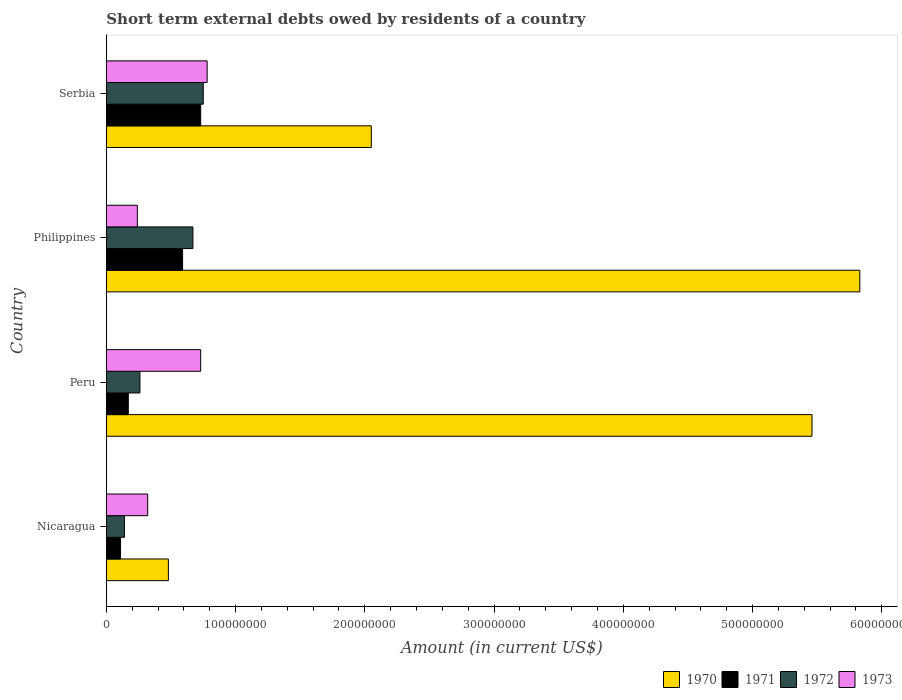How many groups of bars are there?
Ensure brevity in your answer.  4. How many bars are there on the 3rd tick from the top?
Provide a short and direct response. 4. How many bars are there on the 4th tick from the bottom?
Your response must be concise. 4. What is the label of the 4th group of bars from the top?
Make the answer very short. Nicaragua. What is the amount of short-term external debts owed by residents in 1972 in Peru?
Make the answer very short. 2.60e+07. Across all countries, what is the maximum amount of short-term external debts owed by residents in 1970?
Make the answer very short. 5.83e+08. Across all countries, what is the minimum amount of short-term external debts owed by residents in 1971?
Offer a very short reply. 1.10e+07. In which country was the amount of short-term external debts owed by residents in 1973 maximum?
Offer a very short reply. Serbia. In which country was the amount of short-term external debts owed by residents in 1971 minimum?
Offer a very short reply. Nicaragua. What is the total amount of short-term external debts owed by residents in 1970 in the graph?
Keep it short and to the point. 1.38e+09. What is the difference between the amount of short-term external debts owed by residents in 1970 in Nicaragua and that in Serbia?
Your answer should be compact. -1.57e+08. What is the average amount of short-term external debts owed by residents in 1970 per country?
Provide a succinct answer. 3.46e+08. What is the difference between the amount of short-term external debts owed by residents in 1971 and amount of short-term external debts owed by residents in 1973 in Serbia?
Provide a short and direct response. -5.00e+06. In how many countries, is the amount of short-term external debts owed by residents in 1972 greater than 400000000 US$?
Your answer should be compact. 0. What is the ratio of the amount of short-term external debts owed by residents in 1972 in Nicaragua to that in Serbia?
Your answer should be compact. 0.19. Is the amount of short-term external debts owed by residents in 1971 in Philippines less than that in Serbia?
Ensure brevity in your answer.  Yes. Is the difference between the amount of short-term external debts owed by residents in 1971 in Nicaragua and Peru greater than the difference between the amount of short-term external debts owed by residents in 1973 in Nicaragua and Peru?
Keep it short and to the point. Yes. What is the difference between the highest and the second highest amount of short-term external debts owed by residents in 1971?
Provide a short and direct response. 1.40e+07. What is the difference between the highest and the lowest amount of short-term external debts owed by residents in 1970?
Make the answer very short. 5.35e+08. What does the 3rd bar from the top in Peru represents?
Ensure brevity in your answer.  1971. How many bars are there?
Offer a terse response. 16. Are all the bars in the graph horizontal?
Offer a very short reply. Yes. What is the difference between two consecutive major ticks on the X-axis?
Provide a succinct answer. 1.00e+08. Are the values on the major ticks of X-axis written in scientific E-notation?
Offer a terse response. No. Where does the legend appear in the graph?
Offer a terse response. Bottom right. How many legend labels are there?
Give a very brief answer. 4. How are the legend labels stacked?
Provide a short and direct response. Horizontal. What is the title of the graph?
Offer a very short reply. Short term external debts owed by residents of a country. Does "1963" appear as one of the legend labels in the graph?
Offer a very short reply. No. What is the label or title of the X-axis?
Your response must be concise. Amount (in current US$). What is the label or title of the Y-axis?
Provide a short and direct response. Country. What is the Amount (in current US$) of 1970 in Nicaragua?
Your response must be concise. 4.80e+07. What is the Amount (in current US$) in 1971 in Nicaragua?
Ensure brevity in your answer.  1.10e+07. What is the Amount (in current US$) in 1972 in Nicaragua?
Offer a very short reply. 1.40e+07. What is the Amount (in current US$) of 1973 in Nicaragua?
Keep it short and to the point. 3.20e+07. What is the Amount (in current US$) in 1970 in Peru?
Offer a very short reply. 5.46e+08. What is the Amount (in current US$) of 1971 in Peru?
Provide a succinct answer. 1.70e+07. What is the Amount (in current US$) in 1972 in Peru?
Keep it short and to the point. 2.60e+07. What is the Amount (in current US$) in 1973 in Peru?
Ensure brevity in your answer.  7.30e+07. What is the Amount (in current US$) in 1970 in Philippines?
Provide a short and direct response. 5.83e+08. What is the Amount (in current US$) in 1971 in Philippines?
Make the answer very short. 5.90e+07. What is the Amount (in current US$) of 1972 in Philippines?
Offer a very short reply. 6.70e+07. What is the Amount (in current US$) of 1973 in Philippines?
Ensure brevity in your answer.  2.40e+07. What is the Amount (in current US$) of 1970 in Serbia?
Your answer should be compact. 2.05e+08. What is the Amount (in current US$) in 1971 in Serbia?
Keep it short and to the point. 7.30e+07. What is the Amount (in current US$) in 1972 in Serbia?
Ensure brevity in your answer.  7.50e+07. What is the Amount (in current US$) in 1973 in Serbia?
Your answer should be compact. 7.80e+07. Across all countries, what is the maximum Amount (in current US$) of 1970?
Offer a terse response. 5.83e+08. Across all countries, what is the maximum Amount (in current US$) of 1971?
Give a very brief answer. 7.30e+07. Across all countries, what is the maximum Amount (in current US$) in 1972?
Your answer should be very brief. 7.50e+07. Across all countries, what is the maximum Amount (in current US$) in 1973?
Offer a terse response. 7.80e+07. Across all countries, what is the minimum Amount (in current US$) of 1970?
Offer a terse response. 4.80e+07. Across all countries, what is the minimum Amount (in current US$) in 1971?
Provide a succinct answer. 1.10e+07. Across all countries, what is the minimum Amount (in current US$) in 1972?
Make the answer very short. 1.40e+07. Across all countries, what is the minimum Amount (in current US$) of 1973?
Your answer should be very brief. 2.40e+07. What is the total Amount (in current US$) of 1970 in the graph?
Offer a terse response. 1.38e+09. What is the total Amount (in current US$) of 1971 in the graph?
Your answer should be very brief. 1.60e+08. What is the total Amount (in current US$) of 1972 in the graph?
Provide a succinct answer. 1.82e+08. What is the total Amount (in current US$) of 1973 in the graph?
Provide a short and direct response. 2.07e+08. What is the difference between the Amount (in current US$) in 1970 in Nicaragua and that in Peru?
Your response must be concise. -4.98e+08. What is the difference between the Amount (in current US$) in 1971 in Nicaragua and that in Peru?
Your answer should be very brief. -6.00e+06. What is the difference between the Amount (in current US$) in 1972 in Nicaragua and that in Peru?
Keep it short and to the point. -1.20e+07. What is the difference between the Amount (in current US$) in 1973 in Nicaragua and that in Peru?
Provide a short and direct response. -4.10e+07. What is the difference between the Amount (in current US$) in 1970 in Nicaragua and that in Philippines?
Offer a very short reply. -5.35e+08. What is the difference between the Amount (in current US$) in 1971 in Nicaragua and that in Philippines?
Offer a very short reply. -4.80e+07. What is the difference between the Amount (in current US$) in 1972 in Nicaragua and that in Philippines?
Give a very brief answer. -5.30e+07. What is the difference between the Amount (in current US$) in 1973 in Nicaragua and that in Philippines?
Give a very brief answer. 8.00e+06. What is the difference between the Amount (in current US$) of 1970 in Nicaragua and that in Serbia?
Offer a very short reply. -1.57e+08. What is the difference between the Amount (in current US$) in 1971 in Nicaragua and that in Serbia?
Your response must be concise. -6.20e+07. What is the difference between the Amount (in current US$) of 1972 in Nicaragua and that in Serbia?
Your answer should be very brief. -6.10e+07. What is the difference between the Amount (in current US$) of 1973 in Nicaragua and that in Serbia?
Keep it short and to the point. -4.60e+07. What is the difference between the Amount (in current US$) of 1970 in Peru and that in Philippines?
Make the answer very short. -3.70e+07. What is the difference between the Amount (in current US$) of 1971 in Peru and that in Philippines?
Give a very brief answer. -4.20e+07. What is the difference between the Amount (in current US$) in 1972 in Peru and that in Philippines?
Make the answer very short. -4.10e+07. What is the difference between the Amount (in current US$) of 1973 in Peru and that in Philippines?
Offer a very short reply. 4.90e+07. What is the difference between the Amount (in current US$) of 1970 in Peru and that in Serbia?
Ensure brevity in your answer.  3.41e+08. What is the difference between the Amount (in current US$) in 1971 in Peru and that in Serbia?
Provide a succinct answer. -5.60e+07. What is the difference between the Amount (in current US$) in 1972 in Peru and that in Serbia?
Provide a short and direct response. -4.90e+07. What is the difference between the Amount (in current US$) in 1973 in Peru and that in Serbia?
Ensure brevity in your answer.  -5.00e+06. What is the difference between the Amount (in current US$) of 1970 in Philippines and that in Serbia?
Your answer should be compact. 3.78e+08. What is the difference between the Amount (in current US$) of 1971 in Philippines and that in Serbia?
Provide a short and direct response. -1.40e+07. What is the difference between the Amount (in current US$) in 1972 in Philippines and that in Serbia?
Offer a terse response. -8.00e+06. What is the difference between the Amount (in current US$) in 1973 in Philippines and that in Serbia?
Your answer should be compact. -5.40e+07. What is the difference between the Amount (in current US$) of 1970 in Nicaragua and the Amount (in current US$) of 1971 in Peru?
Give a very brief answer. 3.10e+07. What is the difference between the Amount (in current US$) of 1970 in Nicaragua and the Amount (in current US$) of 1972 in Peru?
Your response must be concise. 2.20e+07. What is the difference between the Amount (in current US$) in 1970 in Nicaragua and the Amount (in current US$) in 1973 in Peru?
Your response must be concise. -2.50e+07. What is the difference between the Amount (in current US$) in 1971 in Nicaragua and the Amount (in current US$) in 1972 in Peru?
Give a very brief answer. -1.50e+07. What is the difference between the Amount (in current US$) in 1971 in Nicaragua and the Amount (in current US$) in 1973 in Peru?
Offer a very short reply. -6.20e+07. What is the difference between the Amount (in current US$) in 1972 in Nicaragua and the Amount (in current US$) in 1973 in Peru?
Make the answer very short. -5.90e+07. What is the difference between the Amount (in current US$) in 1970 in Nicaragua and the Amount (in current US$) in 1971 in Philippines?
Ensure brevity in your answer.  -1.10e+07. What is the difference between the Amount (in current US$) in 1970 in Nicaragua and the Amount (in current US$) in 1972 in Philippines?
Make the answer very short. -1.90e+07. What is the difference between the Amount (in current US$) in 1970 in Nicaragua and the Amount (in current US$) in 1973 in Philippines?
Your answer should be compact. 2.40e+07. What is the difference between the Amount (in current US$) of 1971 in Nicaragua and the Amount (in current US$) of 1972 in Philippines?
Your response must be concise. -5.60e+07. What is the difference between the Amount (in current US$) in 1971 in Nicaragua and the Amount (in current US$) in 1973 in Philippines?
Offer a terse response. -1.30e+07. What is the difference between the Amount (in current US$) in 1972 in Nicaragua and the Amount (in current US$) in 1973 in Philippines?
Ensure brevity in your answer.  -1.00e+07. What is the difference between the Amount (in current US$) of 1970 in Nicaragua and the Amount (in current US$) of 1971 in Serbia?
Make the answer very short. -2.50e+07. What is the difference between the Amount (in current US$) of 1970 in Nicaragua and the Amount (in current US$) of 1972 in Serbia?
Offer a very short reply. -2.70e+07. What is the difference between the Amount (in current US$) in 1970 in Nicaragua and the Amount (in current US$) in 1973 in Serbia?
Offer a terse response. -3.00e+07. What is the difference between the Amount (in current US$) of 1971 in Nicaragua and the Amount (in current US$) of 1972 in Serbia?
Give a very brief answer. -6.40e+07. What is the difference between the Amount (in current US$) of 1971 in Nicaragua and the Amount (in current US$) of 1973 in Serbia?
Ensure brevity in your answer.  -6.70e+07. What is the difference between the Amount (in current US$) of 1972 in Nicaragua and the Amount (in current US$) of 1973 in Serbia?
Your answer should be compact. -6.40e+07. What is the difference between the Amount (in current US$) in 1970 in Peru and the Amount (in current US$) in 1971 in Philippines?
Your response must be concise. 4.87e+08. What is the difference between the Amount (in current US$) in 1970 in Peru and the Amount (in current US$) in 1972 in Philippines?
Make the answer very short. 4.79e+08. What is the difference between the Amount (in current US$) of 1970 in Peru and the Amount (in current US$) of 1973 in Philippines?
Your answer should be very brief. 5.22e+08. What is the difference between the Amount (in current US$) in 1971 in Peru and the Amount (in current US$) in 1972 in Philippines?
Your response must be concise. -5.00e+07. What is the difference between the Amount (in current US$) of 1971 in Peru and the Amount (in current US$) of 1973 in Philippines?
Offer a terse response. -7.00e+06. What is the difference between the Amount (in current US$) in 1972 in Peru and the Amount (in current US$) in 1973 in Philippines?
Your answer should be compact. 2.00e+06. What is the difference between the Amount (in current US$) in 1970 in Peru and the Amount (in current US$) in 1971 in Serbia?
Provide a short and direct response. 4.73e+08. What is the difference between the Amount (in current US$) in 1970 in Peru and the Amount (in current US$) in 1972 in Serbia?
Keep it short and to the point. 4.71e+08. What is the difference between the Amount (in current US$) of 1970 in Peru and the Amount (in current US$) of 1973 in Serbia?
Offer a terse response. 4.68e+08. What is the difference between the Amount (in current US$) of 1971 in Peru and the Amount (in current US$) of 1972 in Serbia?
Offer a terse response. -5.80e+07. What is the difference between the Amount (in current US$) of 1971 in Peru and the Amount (in current US$) of 1973 in Serbia?
Make the answer very short. -6.10e+07. What is the difference between the Amount (in current US$) in 1972 in Peru and the Amount (in current US$) in 1973 in Serbia?
Offer a terse response. -5.20e+07. What is the difference between the Amount (in current US$) of 1970 in Philippines and the Amount (in current US$) of 1971 in Serbia?
Provide a succinct answer. 5.10e+08. What is the difference between the Amount (in current US$) of 1970 in Philippines and the Amount (in current US$) of 1972 in Serbia?
Provide a short and direct response. 5.08e+08. What is the difference between the Amount (in current US$) in 1970 in Philippines and the Amount (in current US$) in 1973 in Serbia?
Your answer should be compact. 5.05e+08. What is the difference between the Amount (in current US$) in 1971 in Philippines and the Amount (in current US$) in 1972 in Serbia?
Make the answer very short. -1.60e+07. What is the difference between the Amount (in current US$) of 1971 in Philippines and the Amount (in current US$) of 1973 in Serbia?
Your answer should be very brief. -1.90e+07. What is the difference between the Amount (in current US$) in 1972 in Philippines and the Amount (in current US$) in 1973 in Serbia?
Keep it short and to the point. -1.10e+07. What is the average Amount (in current US$) in 1970 per country?
Offer a very short reply. 3.46e+08. What is the average Amount (in current US$) in 1971 per country?
Offer a very short reply. 4.00e+07. What is the average Amount (in current US$) of 1972 per country?
Keep it short and to the point. 4.55e+07. What is the average Amount (in current US$) in 1973 per country?
Offer a very short reply. 5.18e+07. What is the difference between the Amount (in current US$) in 1970 and Amount (in current US$) in 1971 in Nicaragua?
Offer a very short reply. 3.70e+07. What is the difference between the Amount (in current US$) of 1970 and Amount (in current US$) of 1972 in Nicaragua?
Offer a very short reply. 3.40e+07. What is the difference between the Amount (in current US$) in 1970 and Amount (in current US$) in 1973 in Nicaragua?
Your answer should be compact. 1.60e+07. What is the difference between the Amount (in current US$) of 1971 and Amount (in current US$) of 1972 in Nicaragua?
Your answer should be very brief. -3.00e+06. What is the difference between the Amount (in current US$) in 1971 and Amount (in current US$) in 1973 in Nicaragua?
Ensure brevity in your answer.  -2.10e+07. What is the difference between the Amount (in current US$) in 1972 and Amount (in current US$) in 1973 in Nicaragua?
Keep it short and to the point. -1.80e+07. What is the difference between the Amount (in current US$) in 1970 and Amount (in current US$) in 1971 in Peru?
Give a very brief answer. 5.29e+08. What is the difference between the Amount (in current US$) in 1970 and Amount (in current US$) in 1972 in Peru?
Ensure brevity in your answer.  5.20e+08. What is the difference between the Amount (in current US$) of 1970 and Amount (in current US$) of 1973 in Peru?
Ensure brevity in your answer.  4.73e+08. What is the difference between the Amount (in current US$) in 1971 and Amount (in current US$) in 1972 in Peru?
Your answer should be compact. -9.00e+06. What is the difference between the Amount (in current US$) of 1971 and Amount (in current US$) of 1973 in Peru?
Keep it short and to the point. -5.60e+07. What is the difference between the Amount (in current US$) in 1972 and Amount (in current US$) in 1973 in Peru?
Your answer should be very brief. -4.70e+07. What is the difference between the Amount (in current US$) in 1970 and Amount (in current US$) in 1971 in Philippines?
Ensure brevity in your answer.  5.24e+08. What is the difference between the Amount (in current US$) in 1970 and Amount (in current US$) in 1972 in Philippines?
Make the answer very short. 5.16e+08. What is the difference between the Amount (in current US$) in 1970 and Amount (in current US$) in 1973 in Philippines?
Give a very brief answer. 5.59e+08. What is the difference between the Amount (in current US$) of 1971 and Amount (in current US$) of 1972 in Philippines?
Your answer should be compact. -8.00e+06. What is the difference between the Amount (in current US$) of 1971 and Amount (in current US$) of 1973 in Philippines?
Your answer should be very brief. 3.50e+07. What is the difference between the Amount (in current US$) of 1972 and Amount (in current US$) of 1973 in Philippines?
Offer a very short reply. 4.30e+07. What is the difference between the Amount (in current US$) of 1970 and Amount (in current US$) of 1971 in Serbia?
Your answer should be very brief. 1.32e+08. What is the difference between the Amount (in current US$) in 1970 and Amount (in current US$) in 1972 in Serbia?
Provide a short and direct response. 1.30e+08. What is the difference between the Amount (in current US$) of 1970 and Amount (in current US$) of 1973 in Serbia?
Make the answer very short. 1.27e+08. What is the difference between the Amount (in current US$) in 1971 and Amount (in current US$) in 1973 in Serbia?
Your response must be concise. -5.00e+06. What is the difference between the Amount (in current US$) in 1972 and Amount (in current US$) in 1973 in Serbia?
Make the answer very short. -3.00e+06. What is the ratio of the Amount (in current US$) of 1970 in Nicaragua to that in Peru?
Provide a succinct answer. 0.09. What is the ratio of the Amount (in current US$) in 1971 in Nicaragua to that in Peru?
Keep it short and to the point. 0.65. What is the ratio of the Amount (in current US$) in 1972 in Nicaragua to that in Peru?
Make the answer very short. 0.54. What is the ratio of the Amount (in current US$) of 1973 in Nicaragua to that in Peru?
Give a very brief answer. 0.44. What is the ratio of the Amount (in current US$) in 1970 in Nicaragua to that in Philippines?
Your answer should be compact. 0.08. What is the ratio of the Amount (in current US$) of 1971 in Nicaragua to that in Philippines?
Provide a succinct answer. 0.19. What is the ratio of the Amount (in current US$) of 1972 in Nicaragua to that in Philippines?
Ensure brevity in your answer.  0.21. What is the ratio of the Amount (in current US$) in 1970 in Nicaragua to that in Serbia?
Keep it short and to the point. 0.23. What is the ratio of the Amount (in current US$) of 1971 in Nicaragua to that in Serbia?
Offer a terse response. 0.15. What is the ratio of the Amount (in current US$) in 1972 in Nicaragua to that in Serbia?
Your answer should be compact. 0.19. What is the ratio of the Amount (in current US$) in 1973 in Nicaragua to that in Serbia?
Your answer should be very brief. 0.41. What is the ratio of the Amount (in current US$) of 1970 in Peru to that in Philippines?
Offer a very short reply. 0.94. What is the ratio of the Amount (in current US$) of 1971 in Peru to that in Philippines?
Keep it short and to the point. 0.29. What is the ratio of the Amount (in current US$) of 1972 in Peru to that in Philippines?
Keep it short and to the point. 0.39. What is the ratio of the Amount (in current US$) in 1973 in Peru to that in Philippines?
Give a very brief answer. 3.04. What is the ratio of the Amount (in current US$) in 1970 in Peru to that in Serbia?
Provide a succinct answer. 2.66. What is the ratio of the Amount (in current US$) in 1971 in Peru to that in Serbia?
Provide a short and direct response. 0.23. What is the ratio of the Amount (in current US$) in 1972 in Peru to that in Serbia?
Ensure brevity in your answer.  0.35. What is the ratio of the Amount (in current US$) of 1973 in Peru to that in Serbia?
Ensure brevity in your answer.  0.94. What is the ratio of the Amount (in current US$) of 1970 in Philippines to that in Serbia?
Provide a succinct answer. 2.84. What is the ratio of the Amount (in current US$) in 1971 in Philippines to that in Serbia?
Offer a terse response. 0.81. What is the ratio of the Amount (in current US$) in 1972 in Philippines to that in Serbia?
Ensure brevity in your answer.  0.89. What is the ratio of the Amount (in current US$) in 1973 in Philippines to that in Serbia?
Make the answer very short. 0.31. What is the difference between the highest and the second highest Amount (in current US$) in 1970?
Ensure brevity in your answer.  3.70e+07. What is the difference between the highest and the second highest Amount (in current US$) of 1971?
Provide a short and direct response. 1.40e+07. What is the difference between the highest and the second highest Amount (in current US$) of 1973?
Provide a short and direct response. 5.00e+06. What is the difference between the highest and the lowest Amount (in current US$) in 1970?
Make the answer very short. 5.35e+08. What is the difference between the highest and the lowest Amount (in current US$) in 1971?
Your answer should be very brief. 6.20e+07. What is the difference between the highest and the lowest Amount (in current US$) in 1972?
Offer a very short reply. 6.10e+07. What is the difference between the highest and the lowest Amount (in current US$) of 1973?
Keep it short and to the point. 5.40e+07. 